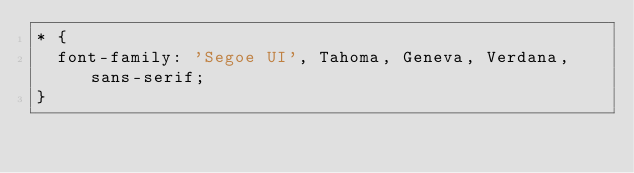Convert code to text. <code><loc_0><loc_0><loc_500><loc_500><_CSS_>* {
  font-family: 'Segoe UI', Tahoma, Geneva, Verdana, sans-serif;
}</code> 